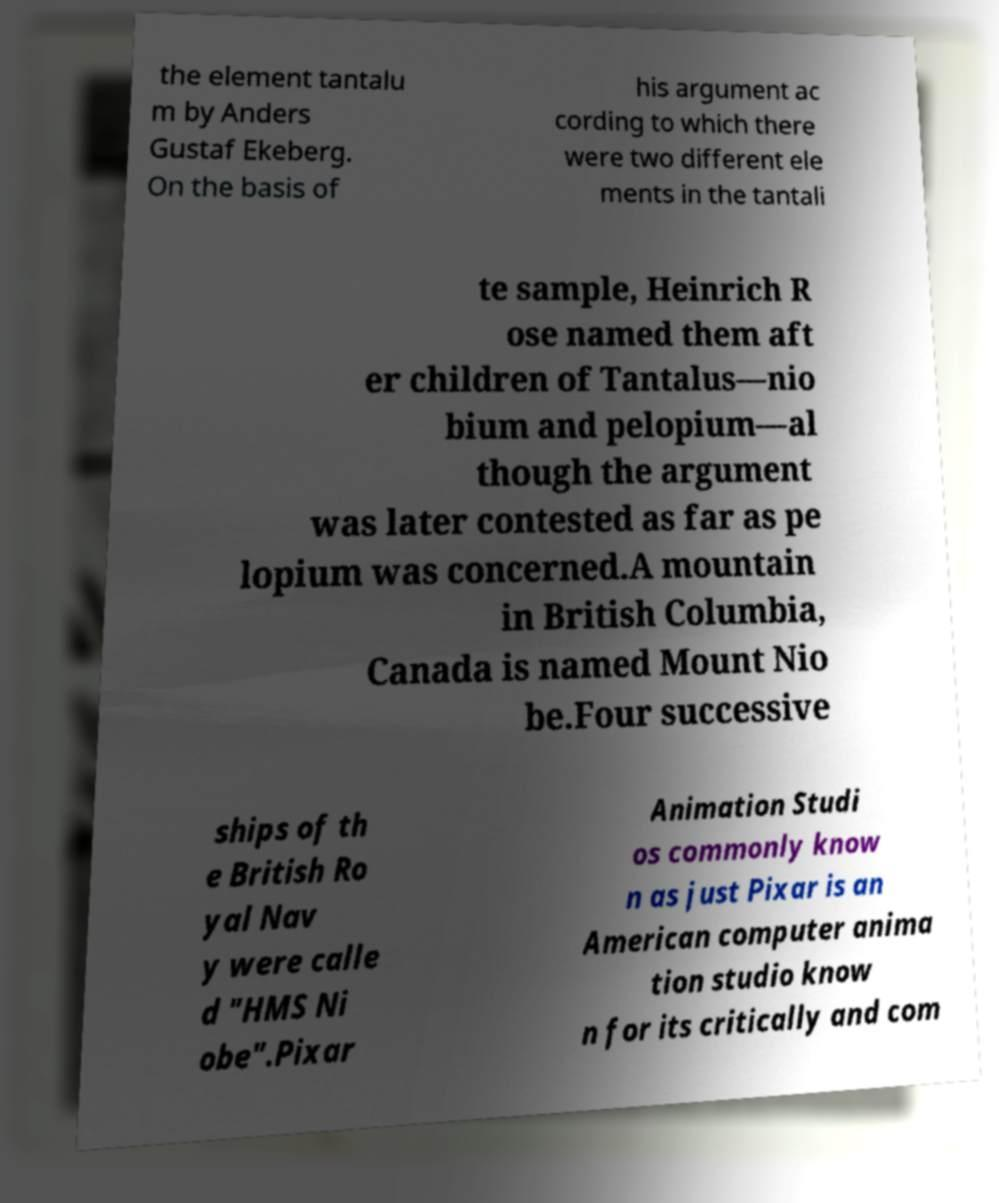What messages or text are displayed in this image? I need them in a readable, typed format. the element tantalu m by Anders Gustaf Ekeberg. On the basis of his argument ac cording to which there were two different ele ments in the tantali te sample, Heinrich R ose named them aft er children of Tantalus—nio bium and pelopium—al though the argument was later contested as far as pe lopium was concerned.A mountain in British Columbia, Canada is named Mount Nio be.Four successive ships of th e British Ro yal Nav y were calle d "HMS Ni obe".Pixar Animation Studi os commonly know n as just Pixar is an American computer anima tion studio know n for its critically and com 